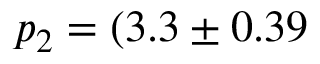<formula> <loc_0><loc_0><loc_500><loc_500>p _ { 2 } = ( 3 . 3 \pm 0 . 3 9</formula> 